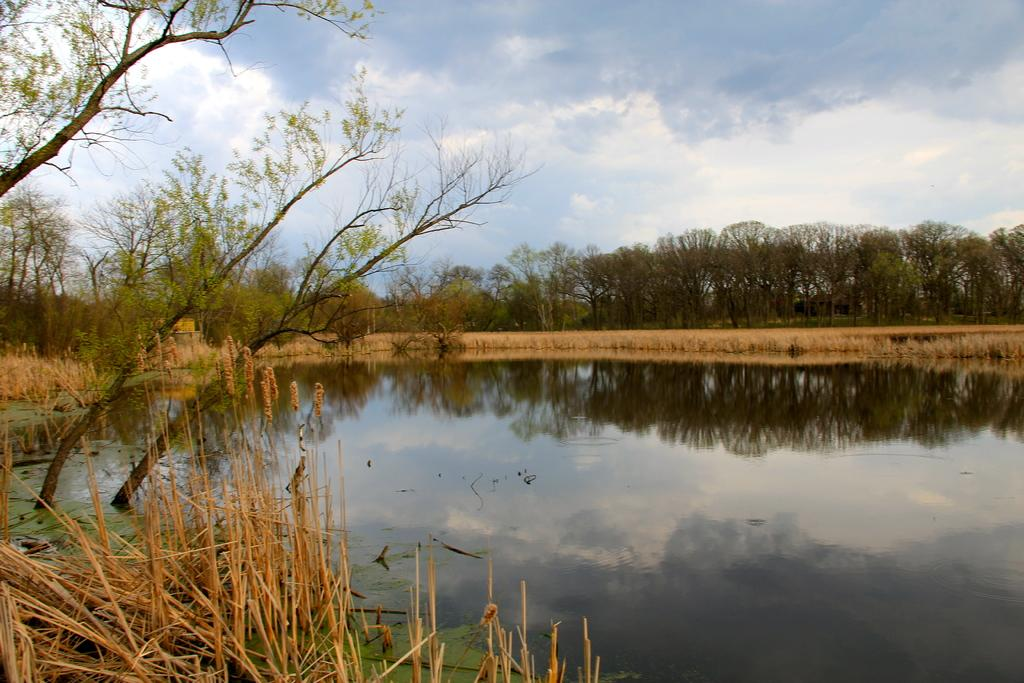What type of plants are in the image? There are dry plants in the image. What else can be seen in the image besides the plants? There is water visible in the image. How many trees are present in the image? There are many trees in the image. What is visible at the top of the image? The sky is clear and visible at the top of the image. What type of mint can be seen growing near the dry plants in the image? There is no mint present in the image; it only features dry plants and other elements mentioned in the facts. 